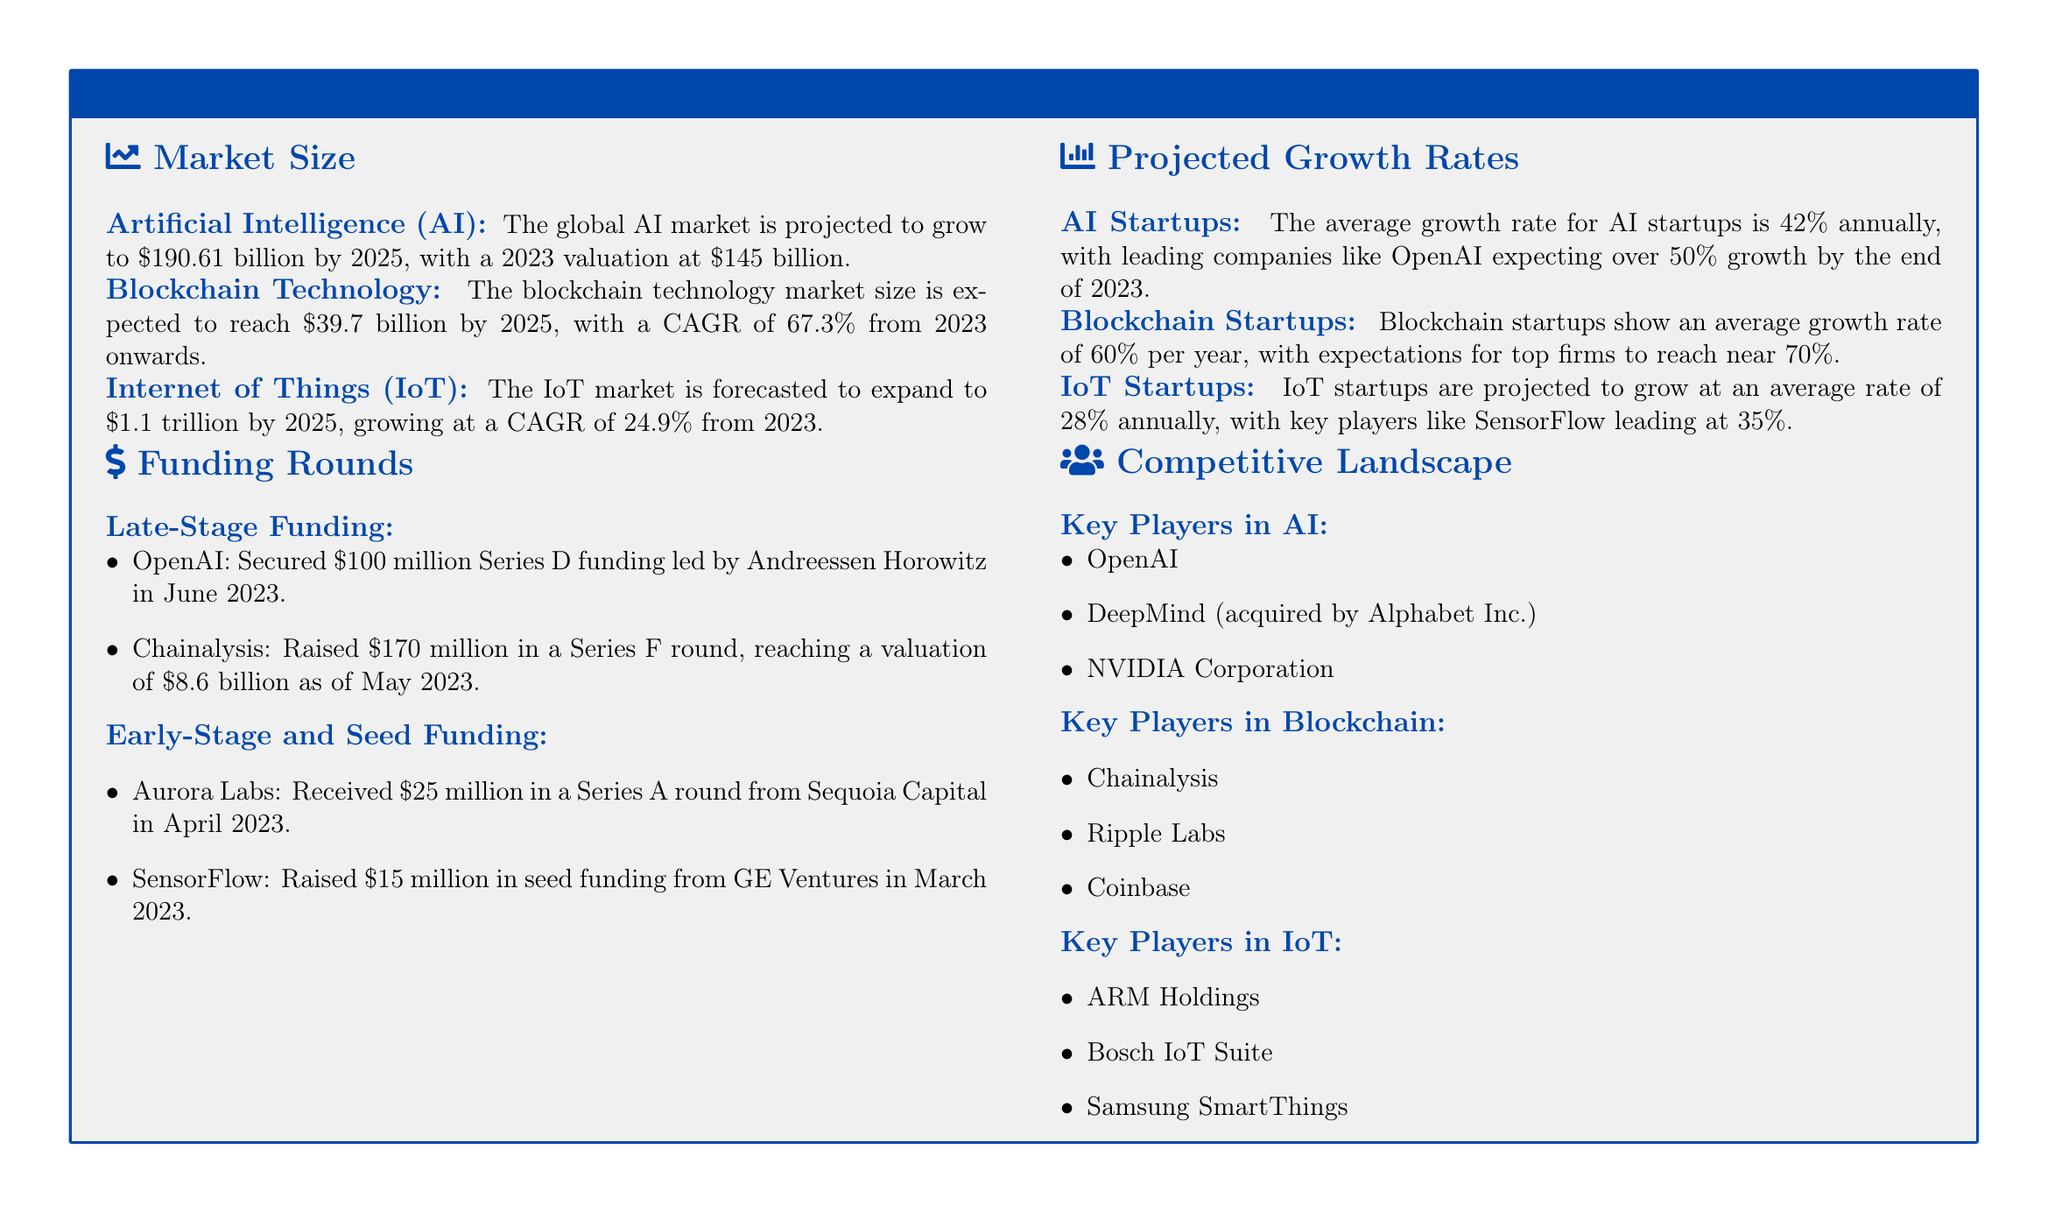What is the projected valuation of the AI market in 2023? The document states that the projected valuation of the AI market in 2023 is $145 billion.
Answer: $145 billion What is the CAGR for blockchain technology from 2023? The CAGR for blockchain technology from 2023 onwards is 67.3%.
Answer: 67.3% How much did OpenAI secure in its Series D funding? OpenAI secured $100 million in its Series D funding.
Answer: $100 million What is the average growth rate for IoT startups? The average growth rate for IoT startups is projected to be 28% annually.
Answer: 28% Who are the key players in the blockchain competitive landscape? The document lists Chainalysis, Ripple Labs, and Coinbase as key players in blockchain.
Answer: Chainalysis, Ripple Labs, Coinbase What is the expected growth rate for leading AI companies by the end of 2023? Leading AI companies, like OpenAI, are expecting over 50% growth by the end of 2023.
Answer: Over 50% Which company raised $170 million in a Series F round? Chainalysis raised $170 million in a Series F round.
Answer: Chainalysis What is the market size for IoT expected to reach by 2025? The IoT market is forecasted to expand to $1.1 trillion by 2025.
Answer: $1.1 trillion What significant funding did SensorFlow receive? SensorFlow received $15 million in seed funding from GE Ventures.
Answer: $15 million 